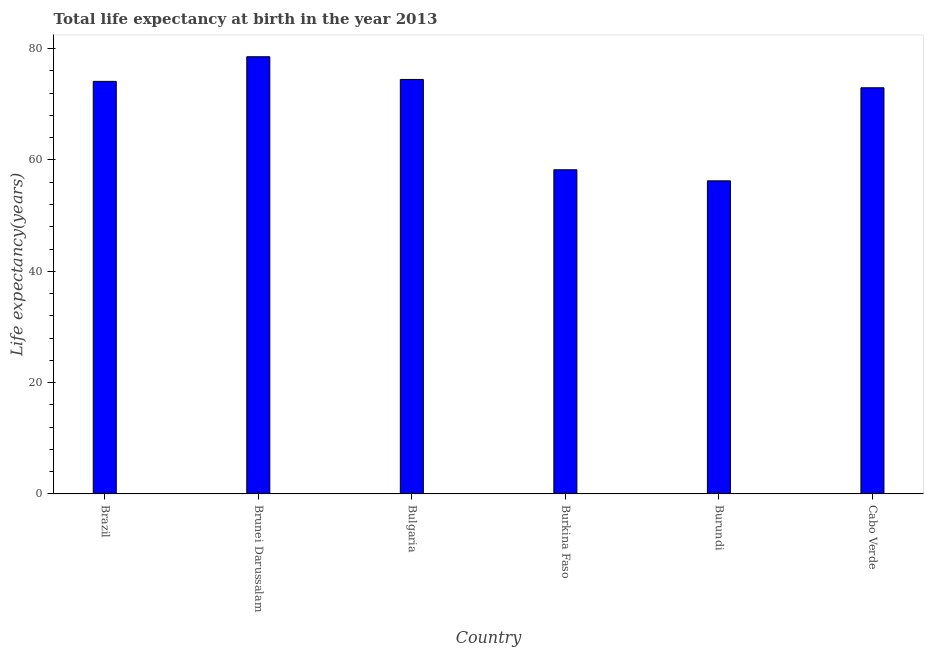What is the title of the graph?
Provide a succinct answer. Total life expectancy at birth in the year 2013. What is the label or title of the Y-axis?
Your response must be concise. Life expectancy(years). What is the life expectancy at birth in Bulgaria?
Make the answer very short. 74.47. Across all countries, what is the maximum life expectancy at birth?
Give a very brief answer. 78.55. Across all countries, what is the minimum life expectancy at birth?
Give a very brief answer. 56.25. In which country was the life expectancy at birth maximum?
Your answer should be compact. Brunei Darussalam. In which country was the life expectancy at birth minimum?
Your answer should be very brief. Burundi. What is the sum of the life expectancy at birth?
Provide a short and direct response. 414.6. What is the difference between the life expectancy at birth in Brazil and Cabo Verde?
Make the answer very short. 1.15. What is the average life expectancy at birth per country?
Your answer should be compact. 69.1. What is the median life expectancy at birth?
Ensure brevity in your answer.  73.55. In how many countries, is the life expectancy at birth greater than 68 years?
Make the answer very short. 4. What is the ratio of the life expectancy at birth in Burundi to that in Cabo Verde?
Give a very brief answer. 0.77. What is the difference between the highest and the second highest life expectancy at birth?
Offer a very short reply. 4.08. Is the sum of the life expectancy at birth in Brunei Darussalam and Burkina Faso greater than the maximum life expectancy at birth across all countries?
Offer a very short reply. Yes. What is the difference between the highest and the lowest life expectancy at birth?
Offer a very short reply. 22.3. How many countries are there in the graph?
Give a very brief answer. 6. What is the difference between two consecutive major ticks on the Y-axis?
Ensure brevity in your answer.  20. Are the values on the major ticks of Y-axis written in scientific E-notation?
Ensure brevity in your answer.  No. What is the Life expectancy(years) in Brazil?
Your response must be concise. 74.12. What is the Life expectancy(years) of Brunei Darussalam?
Your answer should be compact. 78.55. What is the Life expectancy(years) in Bulgaria?
Keep it short and to the point. 74.47. What is the Life expectancy(years) of Burkina Faso?
Give a very brief answer. 58.24. What is the Life expectancy(years) of Burundi?
Keep it short and to the point. 56.25. What is the Life expectancy(years) of Cabo Verde?
Make the answer very short. 72.97. What is the difference between the Life expectancy(years) in Brazil and Brunei Darussalam?
Your answer should be compact. -4.42. What is the difference between the Life expectancy(years) in Brazil and Bulgaria?
Keep it short and to the point. -0.34. What is the difference between the Life expectancy(years) in Brazil and Burkina Faso?
Your response must be concise. 15.88. What is the difference between the Life expectancy(years) in Brazil and Burundi?
Provide a short and direct response. 17.87. What is the difference between the Life expectancy(years) in Brazil and Cabo Verde?
Your answer should be very brief. 1.15. What is the difference between the Life expectancy(years) in Brunei Darussalam and Bulgaria?
Keep it short and to the point. 4.08. What is the difference between the Life expectancy(years) in Brunei Darussalam and Burkina Faso?
Ensure brevity in your answer.  20.31. What is the difference between the Life expectancy(years) in Brunei Darussalam and Burundi?
Provide a succinct answer. 22.3. What is the difference between the Life expectancy(years) in Brunei Darussalam and Cabo Verde?
Provide a short and direct response. 5.57. What is the difference between the Life expectancy(years) in Bulgaria and Burkina Faso?
Keep it short and to the point. 16.23. What is the difference between the Life expectancy(years) in Bulgaria and Burundi?
Ensure brevity in your answer.  18.21. What is the difference between the Life expectancy(years) in Bulgaria and Cabo Verde?
Offer a very short reply. 1.49. What is the difference between the Life expectancy(years) in Burkina Faso and Burundi?
Keep it short and to the point. 1.99. What is the difference between the Life expectancy(years) in Burkina Faso and Cabo Verde?
Ensure brevity in your answer.  -14.73. What is the difference between the Life expectancy(years) in Burundi and Cabo Verde?
Offer a terse response. -16.72. What is the ratio of the Life expectancy(years) in Brazil to that in Brunei Darussalam?
Give a very brief answer. 0.94. What is the ratio of the Life expectancy(years) in Brazil to that in Bulgaria?
Offer a very short reply. 0.99. What is the ratio of the Life expectancy(years) in Brazil to that in Burkina Faso?
Offer a terse response. 1.27. What is the ratio of the Life expectancy(years) in Brazil to that in Burundi?
Give a very brief answer. 1.32. What is the ratio of the Life expectancy(years) in Brunei Darussalam to that in Bulgaria?
Keep it short and to the point. 1.05. What is the ratio of the Life expectancy(years) in Brunei Darussalam to that in Burkina Faso?
Make the answer very short. 1.35. What is the ratio of the Life expectancy(years) in Brunei Darussalam to that in Burundi?
Offer a terse response. 1.4. What is the ratio of the Life expectancy(years) in Brunei Darussalam to that in Cabo Verde?
Your response must be concise. 1.08. What is the ratio of the Life expectancy(years) in Bulgaria to that in Burkina Faso?
Ensure brevity in your answer.  1.28. What is the ratio of the Life expectancy(years) in Bulgaria to that in Burundi?
Ensure brevity in your answer.  1.32. What is the ratio of the Life expectancy(years) in Bulgaria to that in Cabo Verde?
Your answer should be very brief. 1.02. What is the ratio of the Life expectancy(years) in Burkina Faso to that in Burundi?
Ensure brevity in your answer.  1.03. What is the ratio of the Life expectancy(years) in Burkina Faso to that in Cabo Verde?
Offer a very short reply. 0.8. What is the ratio of the Life expectancy(years) in Burundi to that in Cabo Verde?
Give a very brief answer. 0.77. 